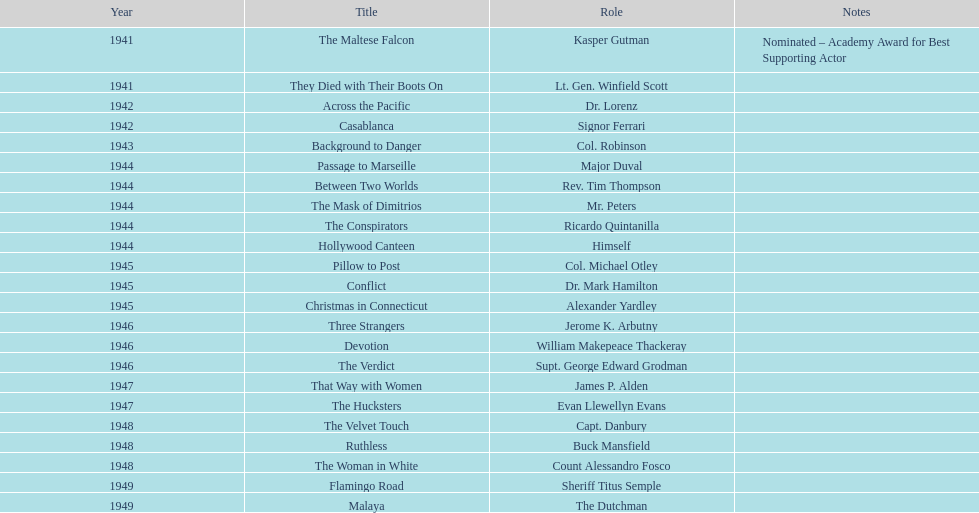What were the 1946 films that included greenstreet in their cast? Three Strangers, Devotion, The Verdict. 